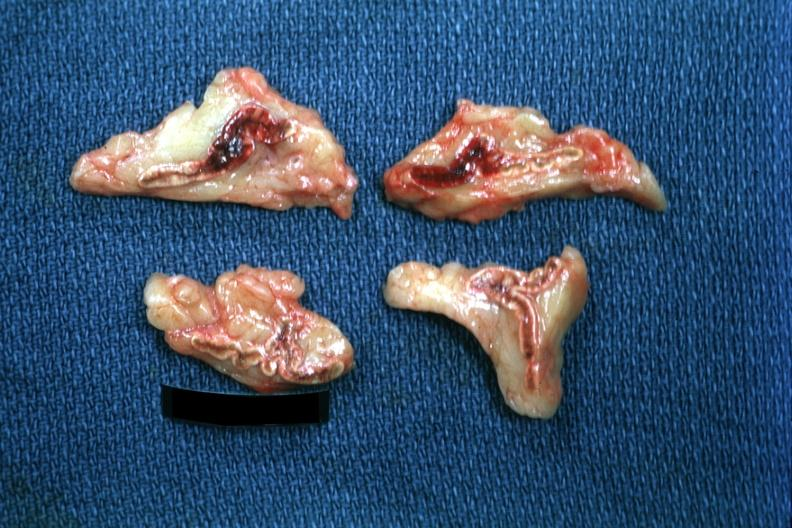where does this belong to?
Answer the question using a single word or phrase. Endocrine system 